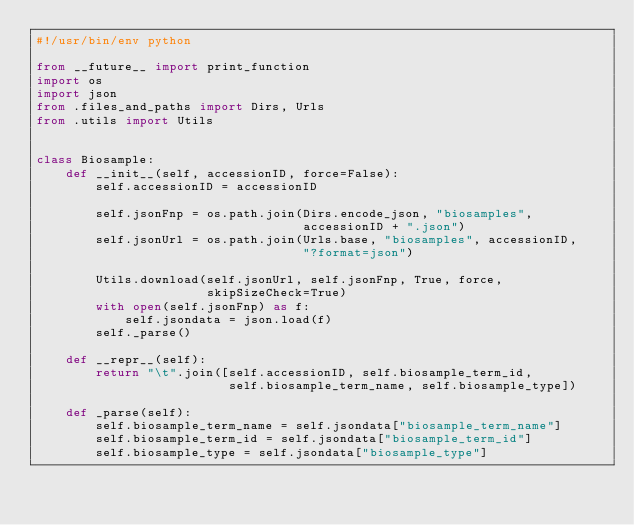<code> <loc_0><loc_0><loc_500><loc_500><_Python_>#!/usr/bin/env python

from __future__ import print_function
import os
import json
from .files_and_paths import Dirs, Urls
from .utils import Utils


class Biosample:
    def __init__(self, accessionID, force=False):
        self.accessionID = accessionID

        self.jsonFnp = os.path.join(Dirs.encode_json, "biosamples",
                                    accessionID + ".json")
        self.jsonUrl = os.path.join(Urls.base, "biosamples", accessionID,
                                    "?format=json")

        Utils.download(self.jsonUrl, self.jsonFnp, True, force,
                       skipSizeCheck=True)
        with open(self.jsonFnp) as f:
            self.jsondata = json.load(f)
        self._parse()

    def __repr__(self):
        return "\t".join([self.accessionID, self.biosample_term_id,
                          self.biosample_term_name, self.biosample_type])

    def _parse(self):
        self.biosample_term_name = self.jsondata["biosample_term_name"]
        self.biosample_term_id = self.jsondata["biosample_term_id"]
        self.biosample_type = self.jsondata["biosample_type"]
</code> 